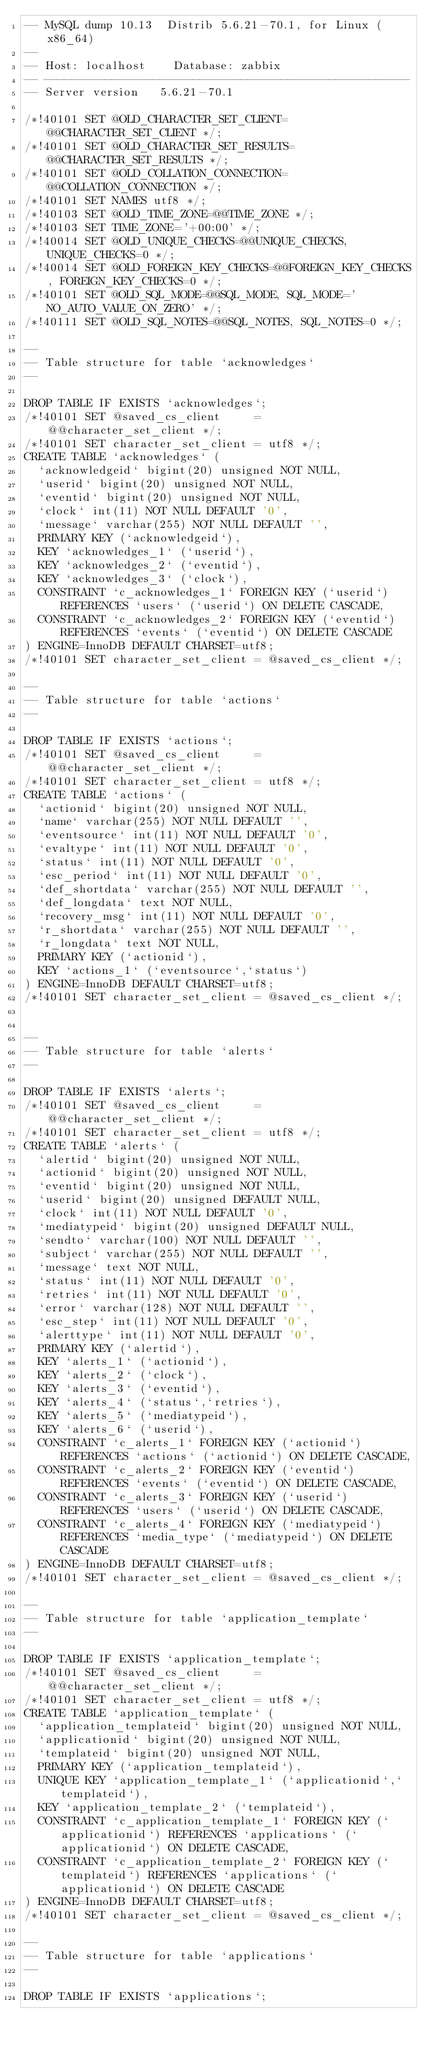<code> <loc_0><loc_0><loc_500><loc_500><_SQL_>-- MySQL dump 10.13  Distrib 5.6.21-70.1, for Linux (x86_64)
--
-- Host: localhost    Database: zabbix
-- ------------------------------------------------------
-- Server version	5.6.21-70.1

/*!40101 SET @OLD_CHARACTER_SET_CLIENT=@@CHARACTER_SET_CLIENT */;
/*!40101 SET @OLD_CHARACTER_SET_RESULTS=@@CHARACTER_SET_RESULTS */;
/*!40101 SET @OLD_COLLATION_CONNECTION=@@COLLATION_CONNECTION */;
/*!40101 SET NAMES utf8 */;
/*!40103 SET @OLD_TIME_ZONE=@@TIME_ZONE */;
/*!40103 SET TIME_ZONE='+00:00' */;
/*!40014 SET @OLD_UNIQUE_CHECKS=@@UNIQUE_CHECKS, UNIQUE_CHECKS=0 */;
/*!40014 SET @OLD_FOREIGN_KEY_CHECKS=@@FOREIGN_KEY_CHECKS, FOREIGN_KEY_CHECKS=0 */;
/*!40101 SET @OLD_SQL_MODE=@@SQL_MODE, SQL_MODE='NO_AUTO_VALUE_ON_ZERO' */;
/*!40111 SET @OLD_SQL_NOTES=@@SQL_NOTES, SQL_NOTES=0 */;

--
-- Table structure for table `acknowledges`
--

DROP TABLE IF EXISTS `acknowledges`;
/*!40101 SET @saved_cs_client     = @@character_set_client */;
/*!40101 SET character_set_client = utf8 */;
CREATE TABLE `acknowledges` (
  `acknowledgeid` bigint(20) unsigned NOT NULL,
  `userid` bigint(20) unsigned NOT NULL,
  `eventid` bigint(20) unsigned NOT NULL,
  `clock` int(11) NOT NULL DEFAULT '0',
  `message` varchar(255) NOT NULL DEFAULT '',
  PRIMARY KEY (`acknowledgeid`),
  KEY `acknowledges_1` (`userid`),
  KEY `acknowledges_2` (`eventid`),
  KEY `acknowledges_3` (`clock`),
  CONSTRAINT `c_acknowledges_1` FOREIGN KEY (`userid`) REFERENCES `users` (`userid`) ON DELETE CASCADE,
  CONSTRAINT `c_acknowledges_2` FOREIGN KEY (`eventid`) REFERENCES `events` (`eventid`) ON DELETE CASCADE
) ENGINE=InnoDB DEFAULT CHARSET=utf8;
/*!40101 SET character_set_client = @saved_cs_client */;

--
-- Table structure for table `actions`
--

DROP TABLE IF EXISTS `actions`;
/*!40101 SET @saved_cs_client     = @@character_set_client */;
/*!40101 SET character_set_client = utf8 */;
CREATE TABLE `actions` (
  `actionid` bigint(20) unsigned NOT NULL,
  `name` varchar(255) NOT NULL DEFAULT '',
  `eventsource` int(11) NOT NULL DEFAULT '0',
  `evaltype` int(11) NOT NULL DEFAULT '0',
  `status` int(11) NOT NULL DEFAULT '0',
  `esc_period` int(11) NOT NULL DEFAULT '0',
  `def_shortdata` varchar(255) NOT NULL DEFAULT '',
  `def_longdata` text NOT NULL,
  `recovery_msg` int(11) NOT NULL DEFAULT '0',
  `r_shortdata` varchar(255) NOT NULL DEFAULT '',
  `r_longdata` text NOT NULL,
  PRIMARY KEY (`actionid`),
  KEY `actions_1` (`eventsource`,`status`)
) ENGINE=InnoDB DEFAULT CHARSET=utf8;
/*!40101 SET character_set_client = @saved_cs_client */;


--
-- Table structure for table `alerts`
--

DROP TABLE IF EXISTS `alerts`;
/*!40101 SET @saved_cs_client     = @@character_set_client */;
/*!40101 SET character_set_client = utf8 */;
CREATE TABLE `alerts` (
  `alertid` bigint(20) unsigned NOT NULL,
  `actionid` bigint(20) unsigned NOT NULL,
  `eventid` bigint(20) unsigned NOT NULL,
  `userid` bigint(20) unsigned DEFAULT NULL,
  `clock` int(11) NOT NULL DEFAULT '0',
  `mediatypeid` bigint(20) unsigned DEFAULT NULL,
  `sendto` varchar(100) NOT NULL DEFAULT '',
  `subject` varchar(255) NOT NULL DEFAULT '',
  `message` text NOT NULL,
  `status` int(11) NOT NULL DEFAULT '0',
  `retries` int(11) NOT NULL DEFAULT '0',
  `error` varchar(128) NOT NULL DEFAULT '',
  `esc_step` int(11) NOT NULL DEFAULT '0',
  `alerttype` int(11) NOT NULL DEFAULT '0',
  PRIMARY KEY (`alertid`),
  KEY `alerts_1` (`actionid`),
  KEY `alerts_2` (`clock`),
  KEY `alerts_3` (`eventid`),
  KEY `alerts_4` (`status`,`retries`),
  KEY `alerts_5` (`mediatypeid`),
  KEY `alerts_6` (`userid`),
  CONSTRAINT `c_alerts_1` FOREIGN KEY (`actionid`) REFERENCES `actions` (`actionid`) ON DELETE CASCADE,
  CONSTRAINT `c_alerts_2` FOREIGN KEY (`eventid`) REFERENCES `events` (`eventid`) ON DELETE CASCADE,
  CONSTRAINT `c_alerts_3` FOREIGN KEY (`userid`) REFERENCES `users` (`userid`) ON DELETE CASCADE,
  CONSTRAINT `c_alerts_4` FOREIGN KEY (`mediatypeid`) REFERENCES `media_type` (`mediatypeid`) ON DELETE CASCADE
) ENGINE=InnoDB DEFAULT CHARSET=utf8;
/*!40101 SET character_set_client = @saved_cs_client */;

--
-- Table structure for table `application_template`
--

DROP TABLE IF EXISTS `application_template`;
/*!40101 SET @saved_cs_client     = @@character_set_client */;
/*!40101 SET character_set_client = utf8 */;
CREATE TABLE `application_template` (
  `application_templateid` bigint(20) unsigned NOT NULL,
  `applicationid` bigint(20) unsigned NOT NULL,
  `templateid` bigint(20) unsigned NOT NULL,
  PRIMARY KEY (`application_templateid`),
  UNIQUE KEY `application_template_1` (`applicationid`,`templateid`),
  KEY `application_template_2` (`templateid`),
  CONSTRAINT `c_application_template_1` FOREIGN KEY (`applicationid`) REFERENCES `applications` (`applicationid`) ON DELETE CASCADE,
  CONSTRAINT `c_application_template_2` FOREIGN KEY (`templateid`) REFERENCES `applications` (`applicationid`) ON DELETE CASCADE
) ENGINE=InnoDB DEFAULT CHARSET=utf8;
/*!40101 SET character_set_client = @saved_cs_client */;

--
-- Table structure for table `applications`
--

DROP TABLE IF EXISTS `applications`;</code> 